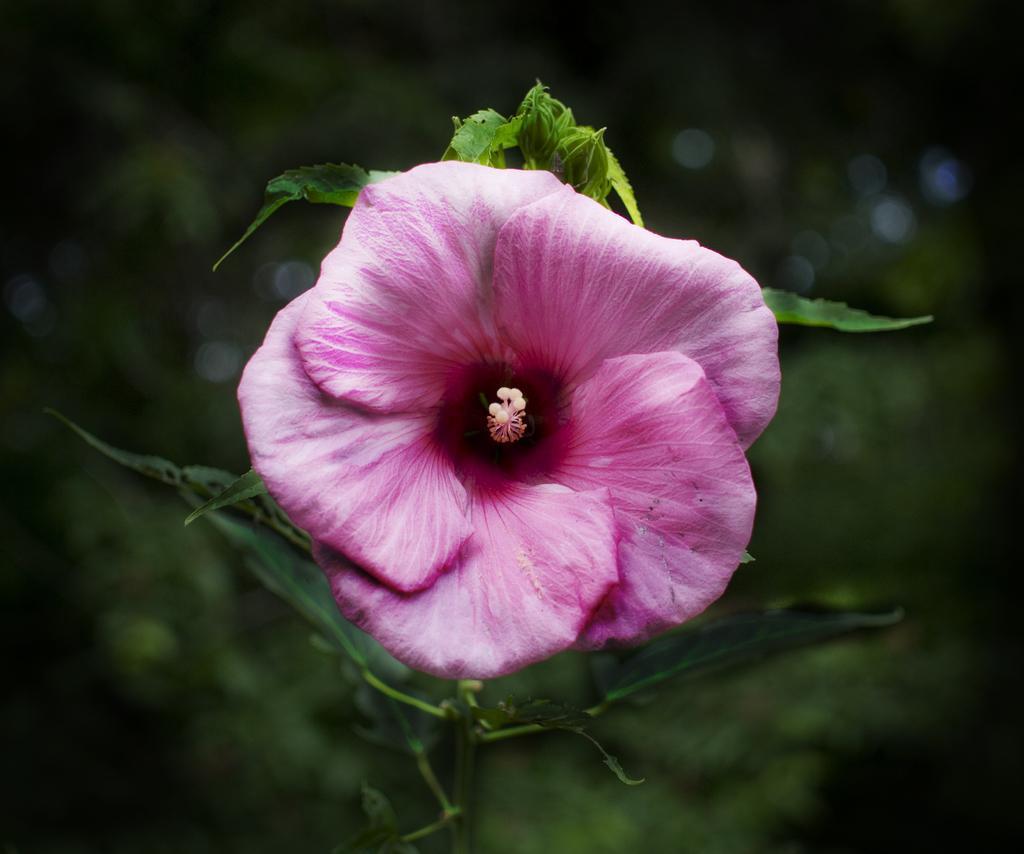Can you describe this image briefly? In the picture there is a beautiful flower and the background of the flower is blue. 